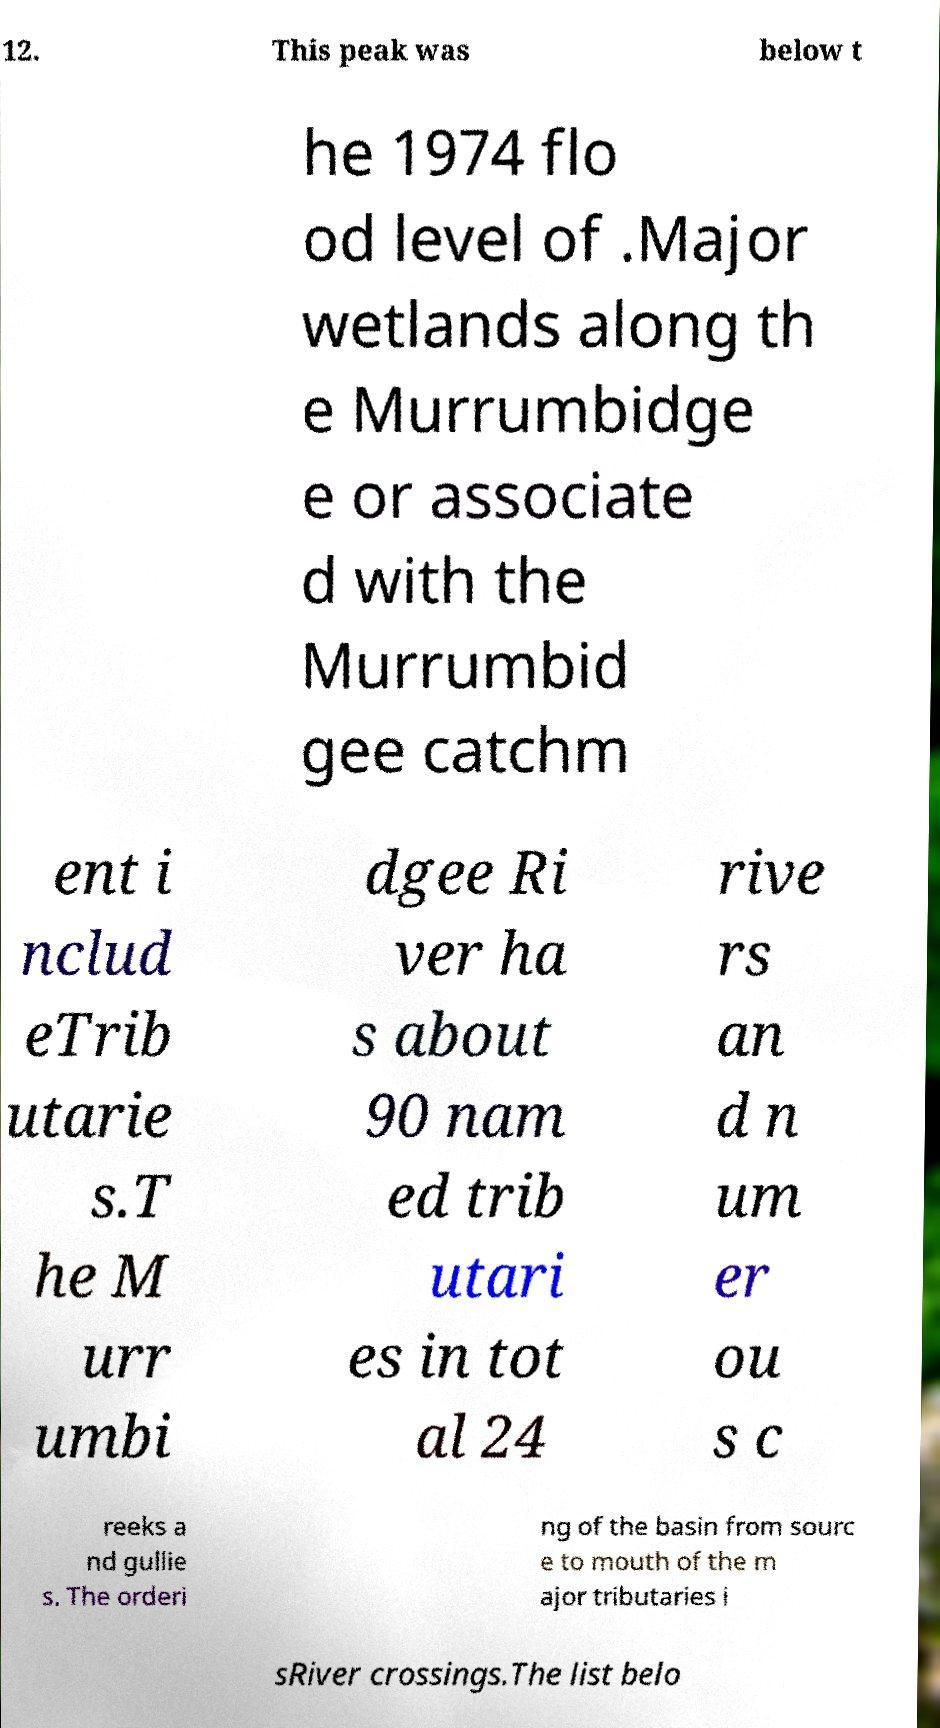Could you extract and type out the text from this image? 12. This peak was below t he 1974 flo od level of .Major wetlands along th e Murrumbidge e or associate d with the Murrumbid gee catchm ent i nclud eTrib utarie s.T he M urr umbi dgee Ri ver ha s about 90 nam ed trib utari es in tot al 24 rive rs an d n um er ou s c reeks a nd gullie s. The orderi ng of the basin from sourc e to mouth of the m ajor tributaries i sRiver crossings.The list belo 